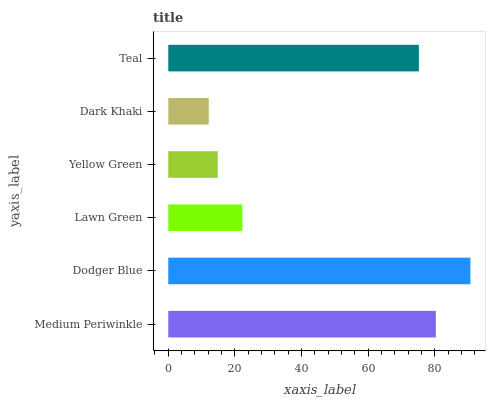Is Dark Khaki the minimum?
Answer yes or no. Yes. Is Dodger Blue the maximum?
Answer yes or no. Yes. Is Lawn Green the minimum?
Answer yes or no. No. Is Lawn Green the maximum?
Answer yes or no. No. Is Dodger Blue greater than Lawn Green?
Answer yes or no. Yes. Is Lawn Green less than Dodger Blue?
Answer yes or no. Yes. Is Lawn Green greater than Dodger Blue?
Answer yes or no. No. Is Dodger Blue less than Lawn Green?
Answer yes or no. No. Is Teal the high median?
Answer yes or no. Yes. Is Lawn Green the low median?
Answer yes or no. Yes. Is Dodger Blue the high median?
Answer yes or no. No. Is Yellow Green the low median?
Answer yes or no. No. 